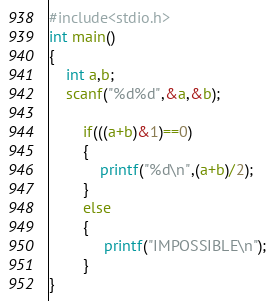Convert code to text. <code><loc_0><loc_0><loc_500><loc_500><_Awk_>#include<stdio.h>
int main()
{
    int a,b;
    scanf("%d%d",&a,&b);

        if(((a+b)&1)==0)
        {
            printf("%d\n",(a+b)/2);
        }
        else
        {
             printf("IMPOSSIBLE\n");
        }
}</code> 